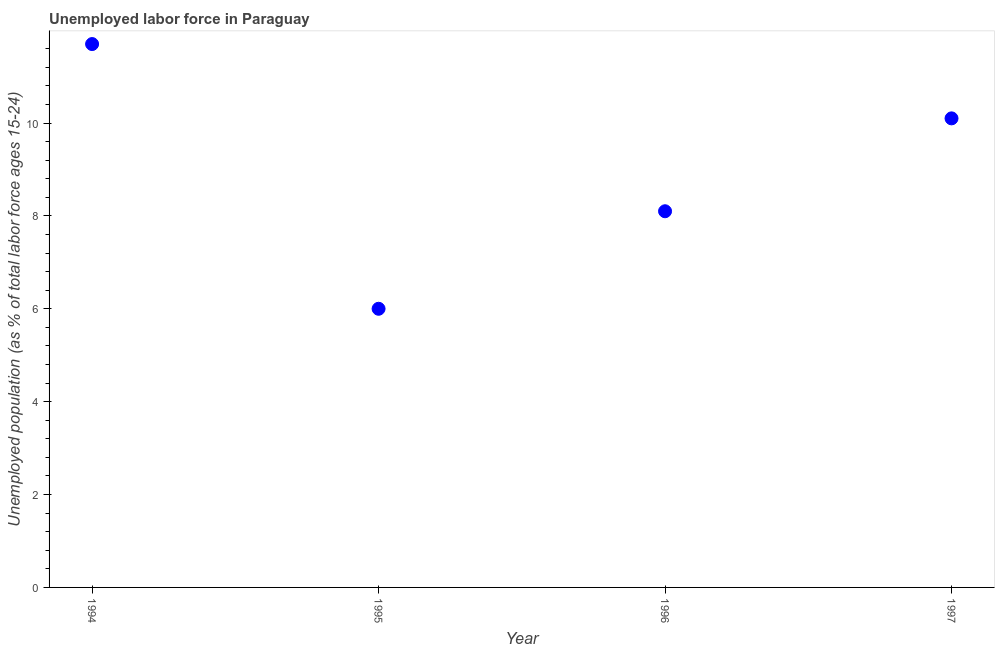What is the total unemployed youth population in 1997?
Ensure brevity in your answer.  10.1. Across all years, what is the maximum total unemployed youth population?
Your answer should be compact. 11.7. Across all years, what is the minimum total unemployed youth population?
Your answer should be very brief. 6. In which year was the total unemployed youth population maximum?
Your answer should be compact. 1994. What is the sum of the total unemployed youth population?
Keep it short and to the point. 35.9. What is the difference between the total unemployed youth population in 1994 and 1997?
Your answer should be very brief. 1.6. What is the average total unemployed youth population per year?
Make the answer very short. 8.98. What is the median total unemployed youth population?
Keep it short and to the point. 9.1. What is the ratio of the total unemployed youth population in 1995 to that in 1997?
Offer a very short reply. 0.59. What is the difference between the highest and the second highest total unemployed youth population?
Keep it short and to the point. 1.6. What is the difference between the highest and the lowest total unemployed youth population?
Your answer should be very brief. 5.7. In how many years, is the total unemployed youth population greater than the average total unemployed youth population taken over all years?
Offer a very short reply. 2. How many dotlines are there?
Make the answer very short. 1. How many years are there in the graph?
Give a very brief answer. 4. What is the difference between two consecutive major ticks on the Y-axis?
Your response must be concise. 2. Are the values on the major ticks of Y-axis written in scientific E-notation?
Your response must be concise. No. Does the graph contain grids?
Give a very brief answer. No. What is the title of the graph?
Ensure brevity in your answer.  Unemployed labor force in Paraguay. What is the label or title of the Y-axis?
Offer a very short reply. Unemployed population (as % of total labor force ages 15-24). What is the Unemployed population (as % of total labor force ages 15-24) in 1994?
Make the answer very short. 11.7. What is the Unemployed population (as % of total labor force ages 15-24) in 1996?
Provide a succinct answer. 8.1. What is the Unemployed population (as % of total labor force ages 15-24) in 1997?
Make the answer very short. 10.1. What is the difference between the Unemployed population (as % of total labor force ages 15-24) in 1995 and 1996?
Your answer should be compact. -2.1. What is the ratio of the Unemployed population (as % of total labor force ages 15-24) in 1994 to that in 1995?
Offer a very short reply. 1.95. What is the ratio of the Unemployed population (as % of total labor force ages 15-24) in 1994 to that in 1996?
Your answer should be compact. 1.44. What is the ratio of the Unemployed population (as % of total labor force ages 15-24) in 1994 to that in 1997?
Your answer should be compact. 1.16. What is the ratio of the Unemployed population (as % of total labor force ages 15-24) in 1995 to that in 1996?
Your response must be concise. 0.74. What is the ratio of the Unemployed population (as % of total labor force ages 15-24) in 1995 to that in 1997?
Offer a very short reply. 0.59. What is the ratio of the Unemployed population (as % of total labor force ages 15-24) in 1996 to that in 1997?
Your answer should be compact. 0.8. 